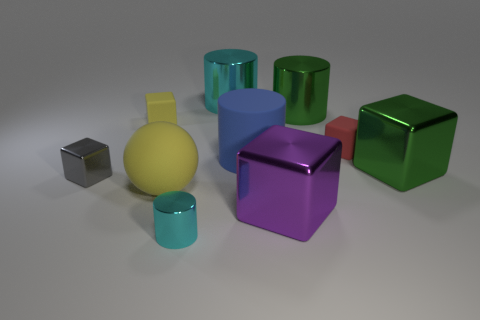There is a metallic thing that is the same color as the tiny metallic cylinder; what is its size?
Keep it short and to the point. Large. The metal object that is the same color as the small metal cylinder is what shape?
Offer a terse response. Cylinder. Are there any other things of the same color as the rubber cylinder?
Your answer should be compact. No. The small metal object left of the yellow matte cube has what shape?
Give a very brief answer. Cube. There is a large matte sphere; does it have the same color as the rubber cube that is on the left side of the blue cylinder?
Your answer should be very brief. Yes. Are there the same number of green metal blocks in front of the tiny metallic cylinder and small cylinders that are right of the large green shiny cylinder?
Offer a terse response. Yes. How many other things are there of the same size as the purple block?
Keep it short and to the point. 5. The yellow rubber ball has what size?
Offer a very short reply. Large. Does the gray cube have the same material as the tiny block that is to the right of the big blue rubber object?
Ensure brevity in your answer.  No. Are there any large green things of the same shape as the gray thing?
Provide a succinct answer. Yes. 